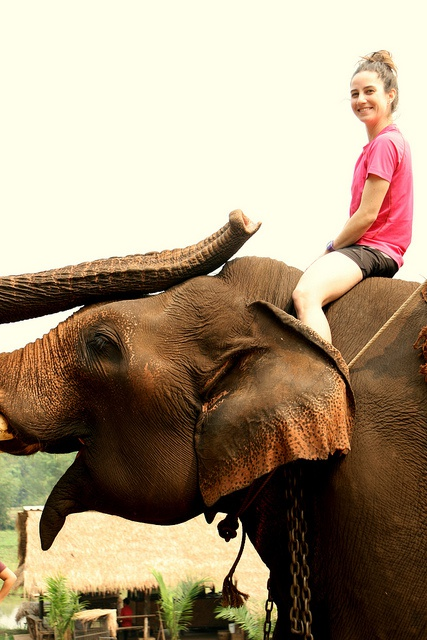Describe the objects in this image and their specific colors. I can see elephant in ivory, black, maroon, and brown tones and people in ivory, beige, lightpink, salmon, and tan tones in this image. 